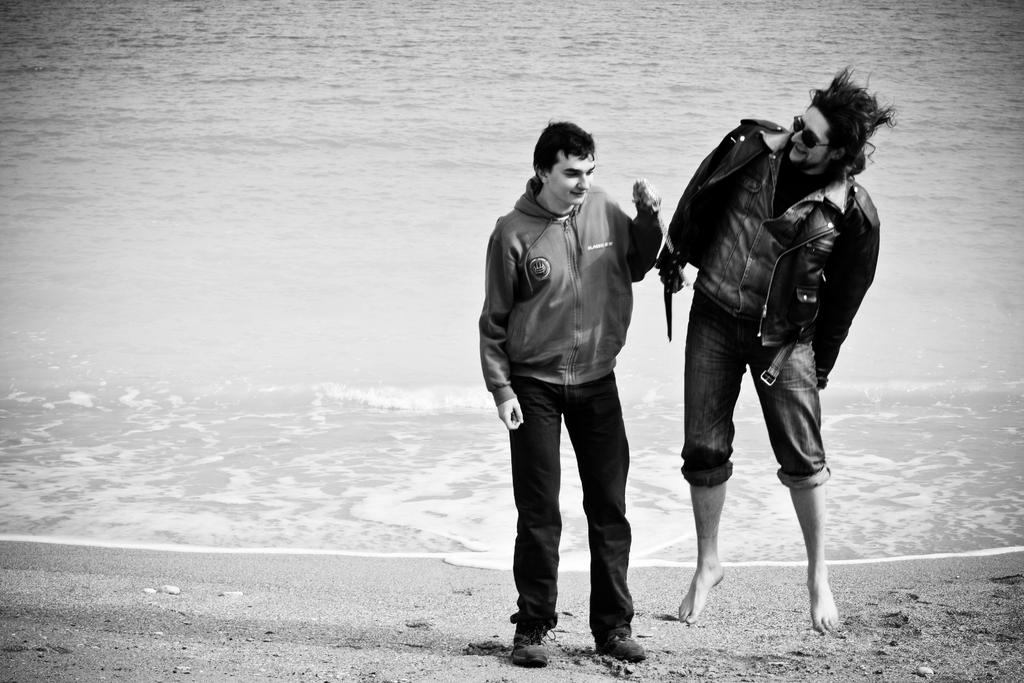How many people are in the image? There are two men in the image. Can you describe the appearance of one of the men? The man on the right side is wearing spectacles. What is visible in the background of the image? There is water visible behind the men. What is the color scheme of the image? The photograph is in black and white. Can you tell me how many wounds are visible on the men in the image? There are no visible wounds on the men in the image. What type of account is being discussed by the men in the image? There is no indication of any discussion or account in the image; it simply features two men and water in the background. 